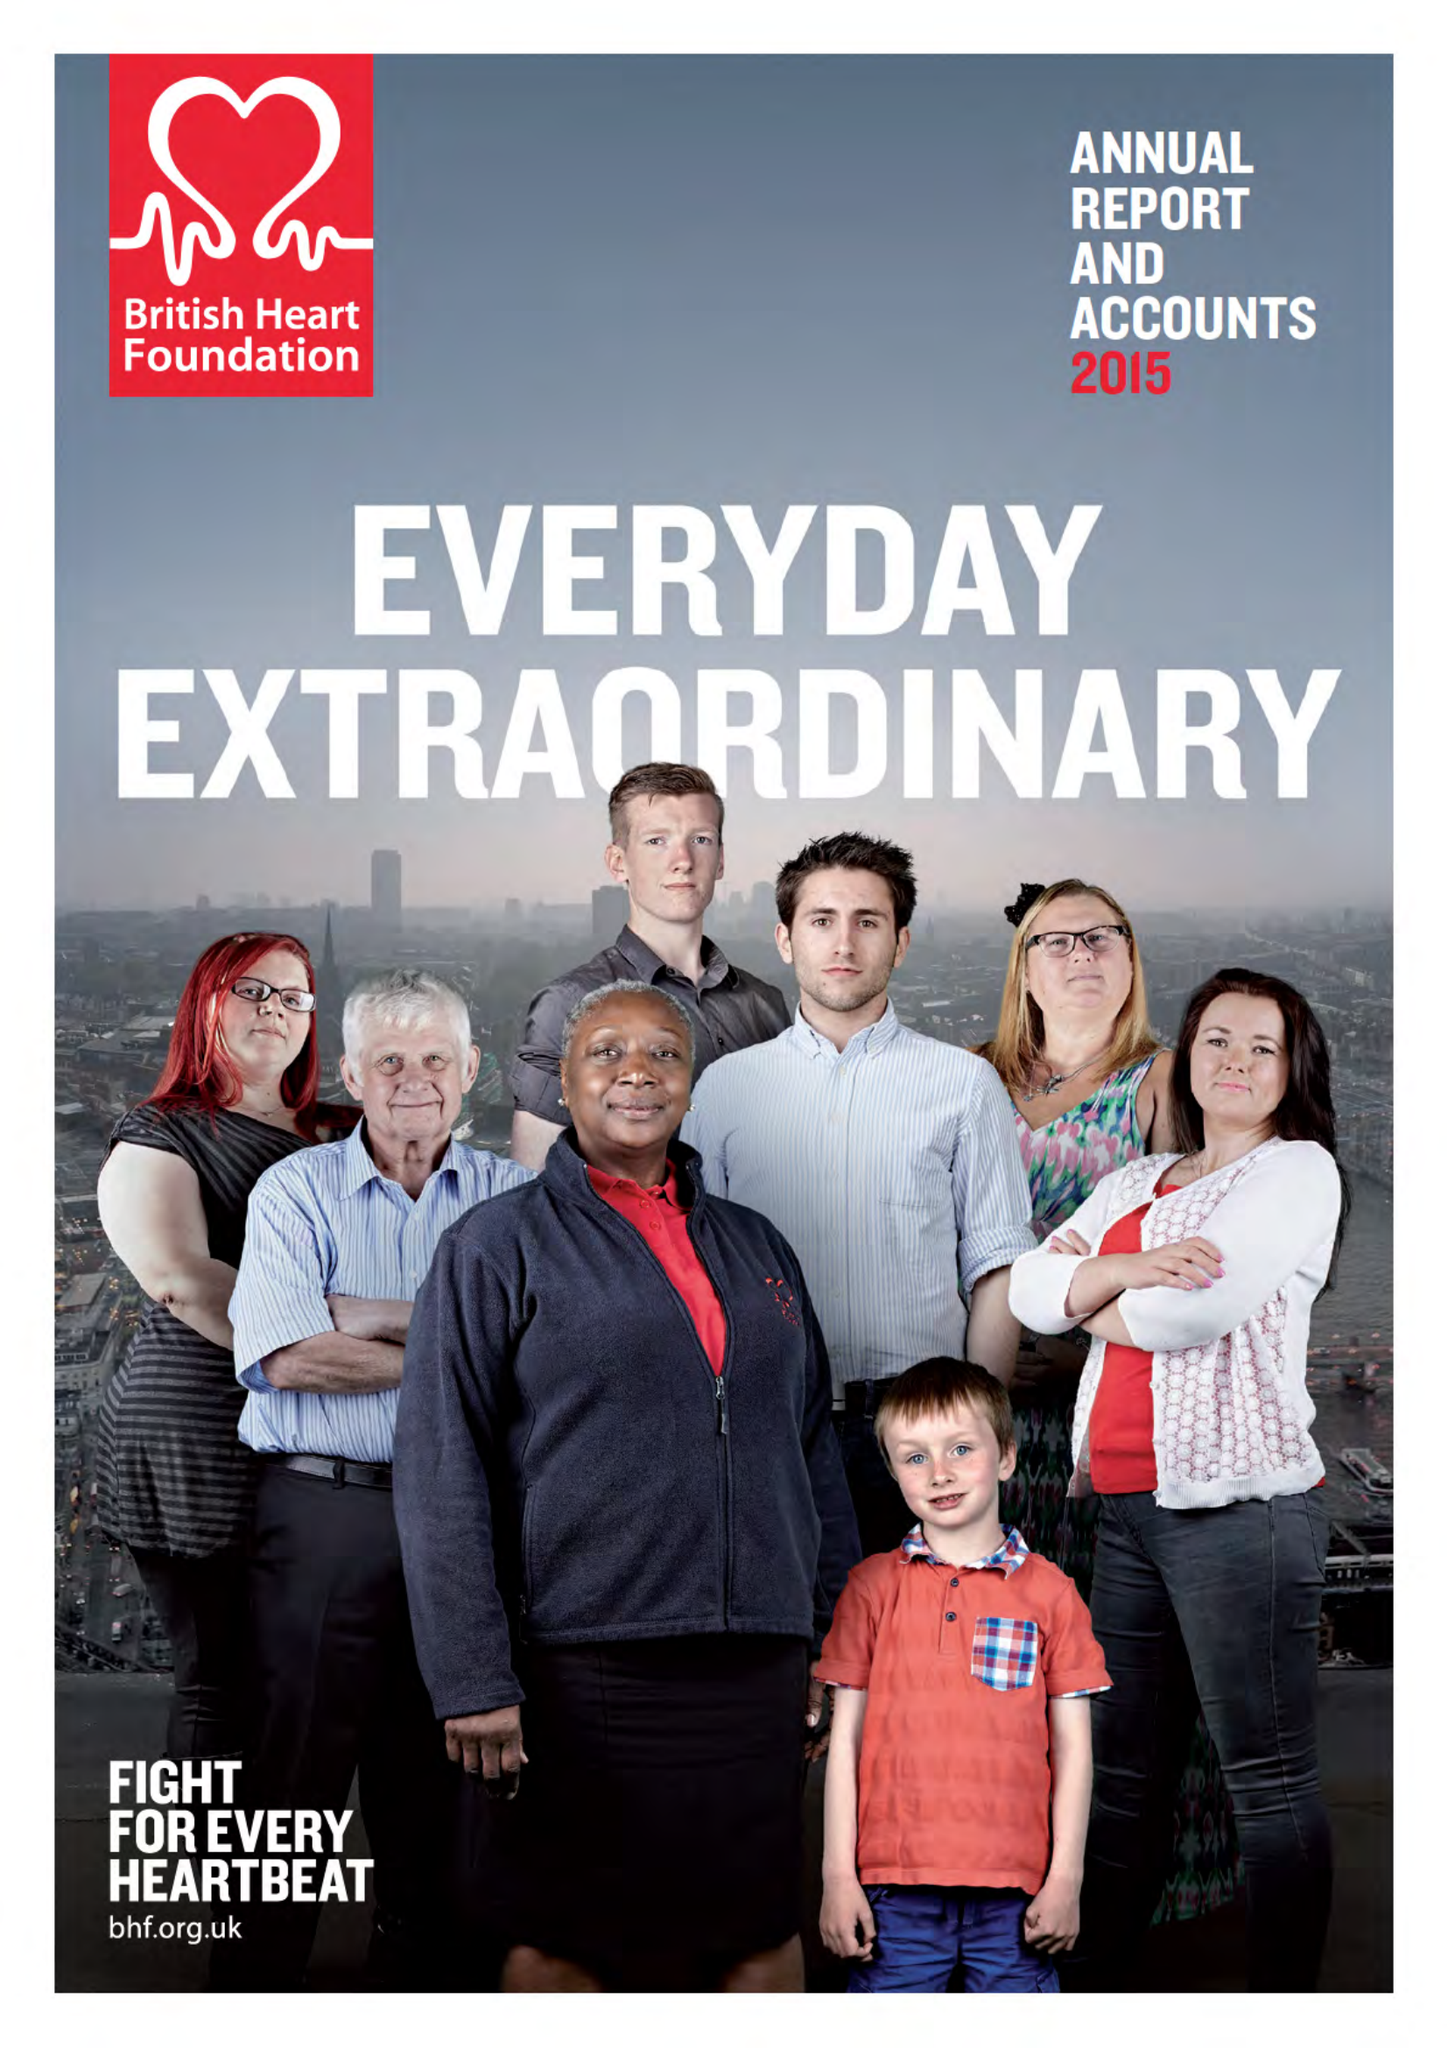What is the value for the charity_number?
Answer the question using a single word or phrase. 225971 